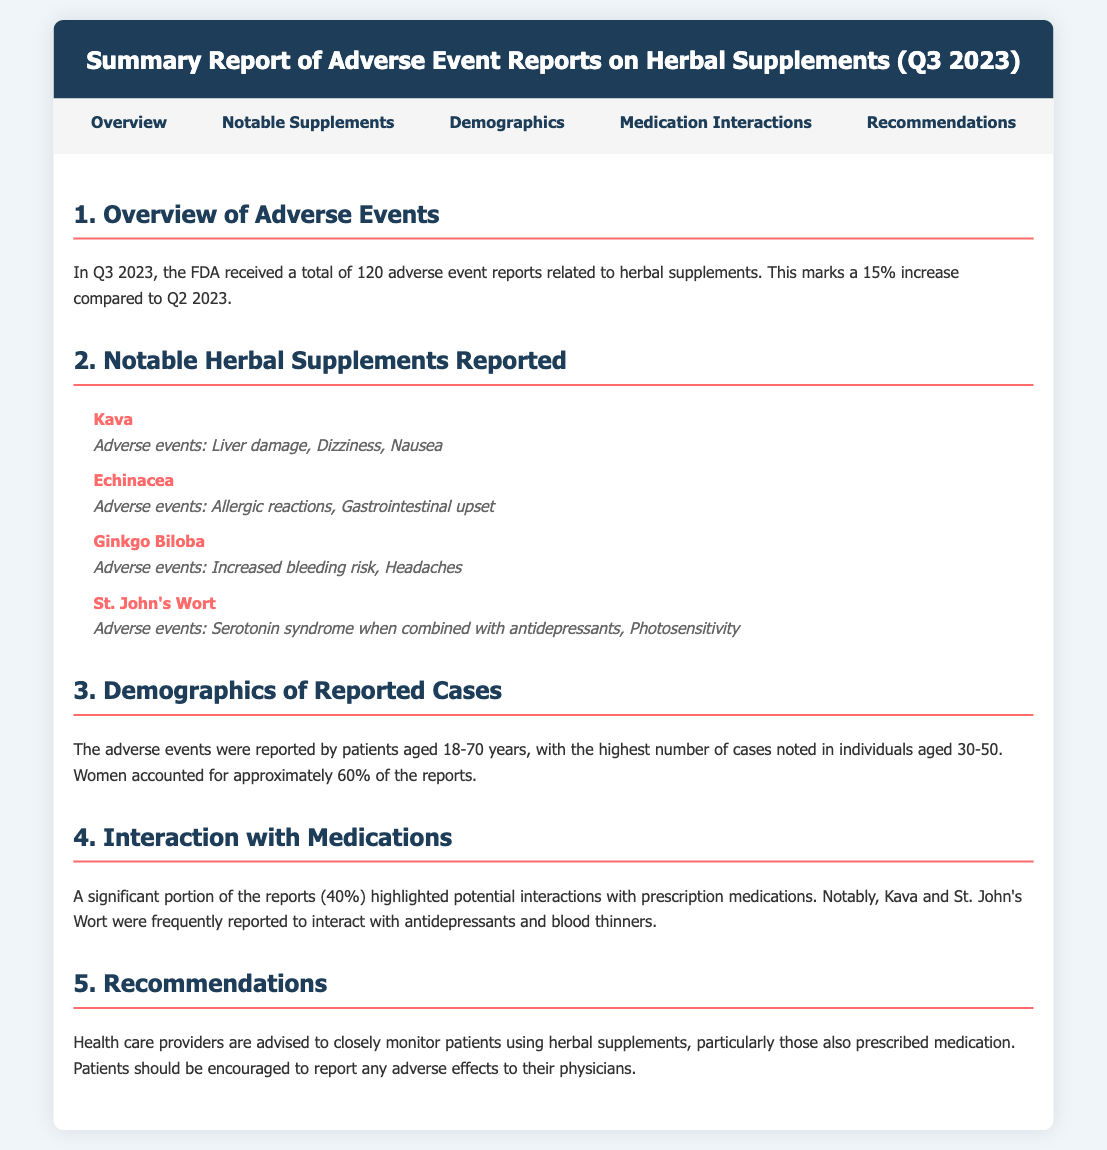What was the total number of adverse event reports received? The document states that the FDA received a total of 120 adverse event reports related to herbal supplements in Q3 2023.
Answer: 120 By what percentage did adverse event reports increase compared to Q2 2023? The report mentions that there was a 15% increase in adverse event reports compared to Q2 2023.
Answer: 15% Which herbal supplement is associated with liver damage? Kava is noted in the document to have liver damage as an adverse event.
Answer: Kava What percentage of reported cases involved women? The document indicates that women accounted for approximately 60% of the reports.
Answer: 60% Which herb was frequently reported to interact with antidepressants? Kava and St. John's Wort were frequently reported to interact with antidepressants according to the document.
Answer: Kava and St. John's Wort What are the notable adverse events associated with Echinacea? The document lists allergic reactions and gastrointestinal upset as notable adverse events for Echinacea.
Answer: Allergic reactions, Gastrointestinal upset In which age group were the highest number of adverse event cases noted? The document specifies that the highest number of cases was noted in individuals aged 30-50 years.
Answer: 30-50 What is the primary recommendation for healthcare providers? The document recommends that healthcare providers closely monitor patients using herbal supplements, especially those prescribed medication.
Answer: Monitor patients closely What type of report does this document summarize? This document summarizes a report regarding adverse events related to herbal supplements.
Answer: Adverse event report 